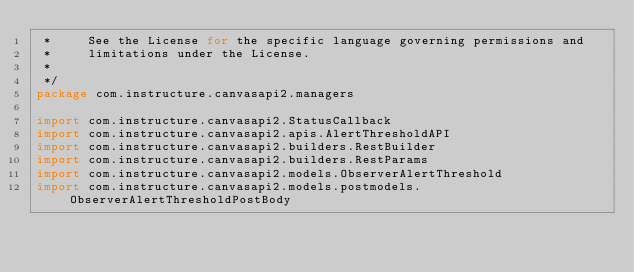<code> <loc_0><loc_0><loc_500><loc_500><_Kotlin_> *     See the License for the specific language governing permissions and
 *     limitations under the License.
 *
 */
package com.instructure.canvasapi2.managers

import com.instructure.canvasapi2.StatusCallback
import com.instructure.canvasapi2.apis.AlertThresholdAPI
import com.instructure.canvasapi2.builders.RestBuilder
import com.instructure.canvasapi2.builders.RestParams
import com.instructure.canvasapi2.models.ObserverAlertThreshold
import com.instructure.canvasapi2.models.postmodels.ObserverAlertThresholdPostBody</code> 